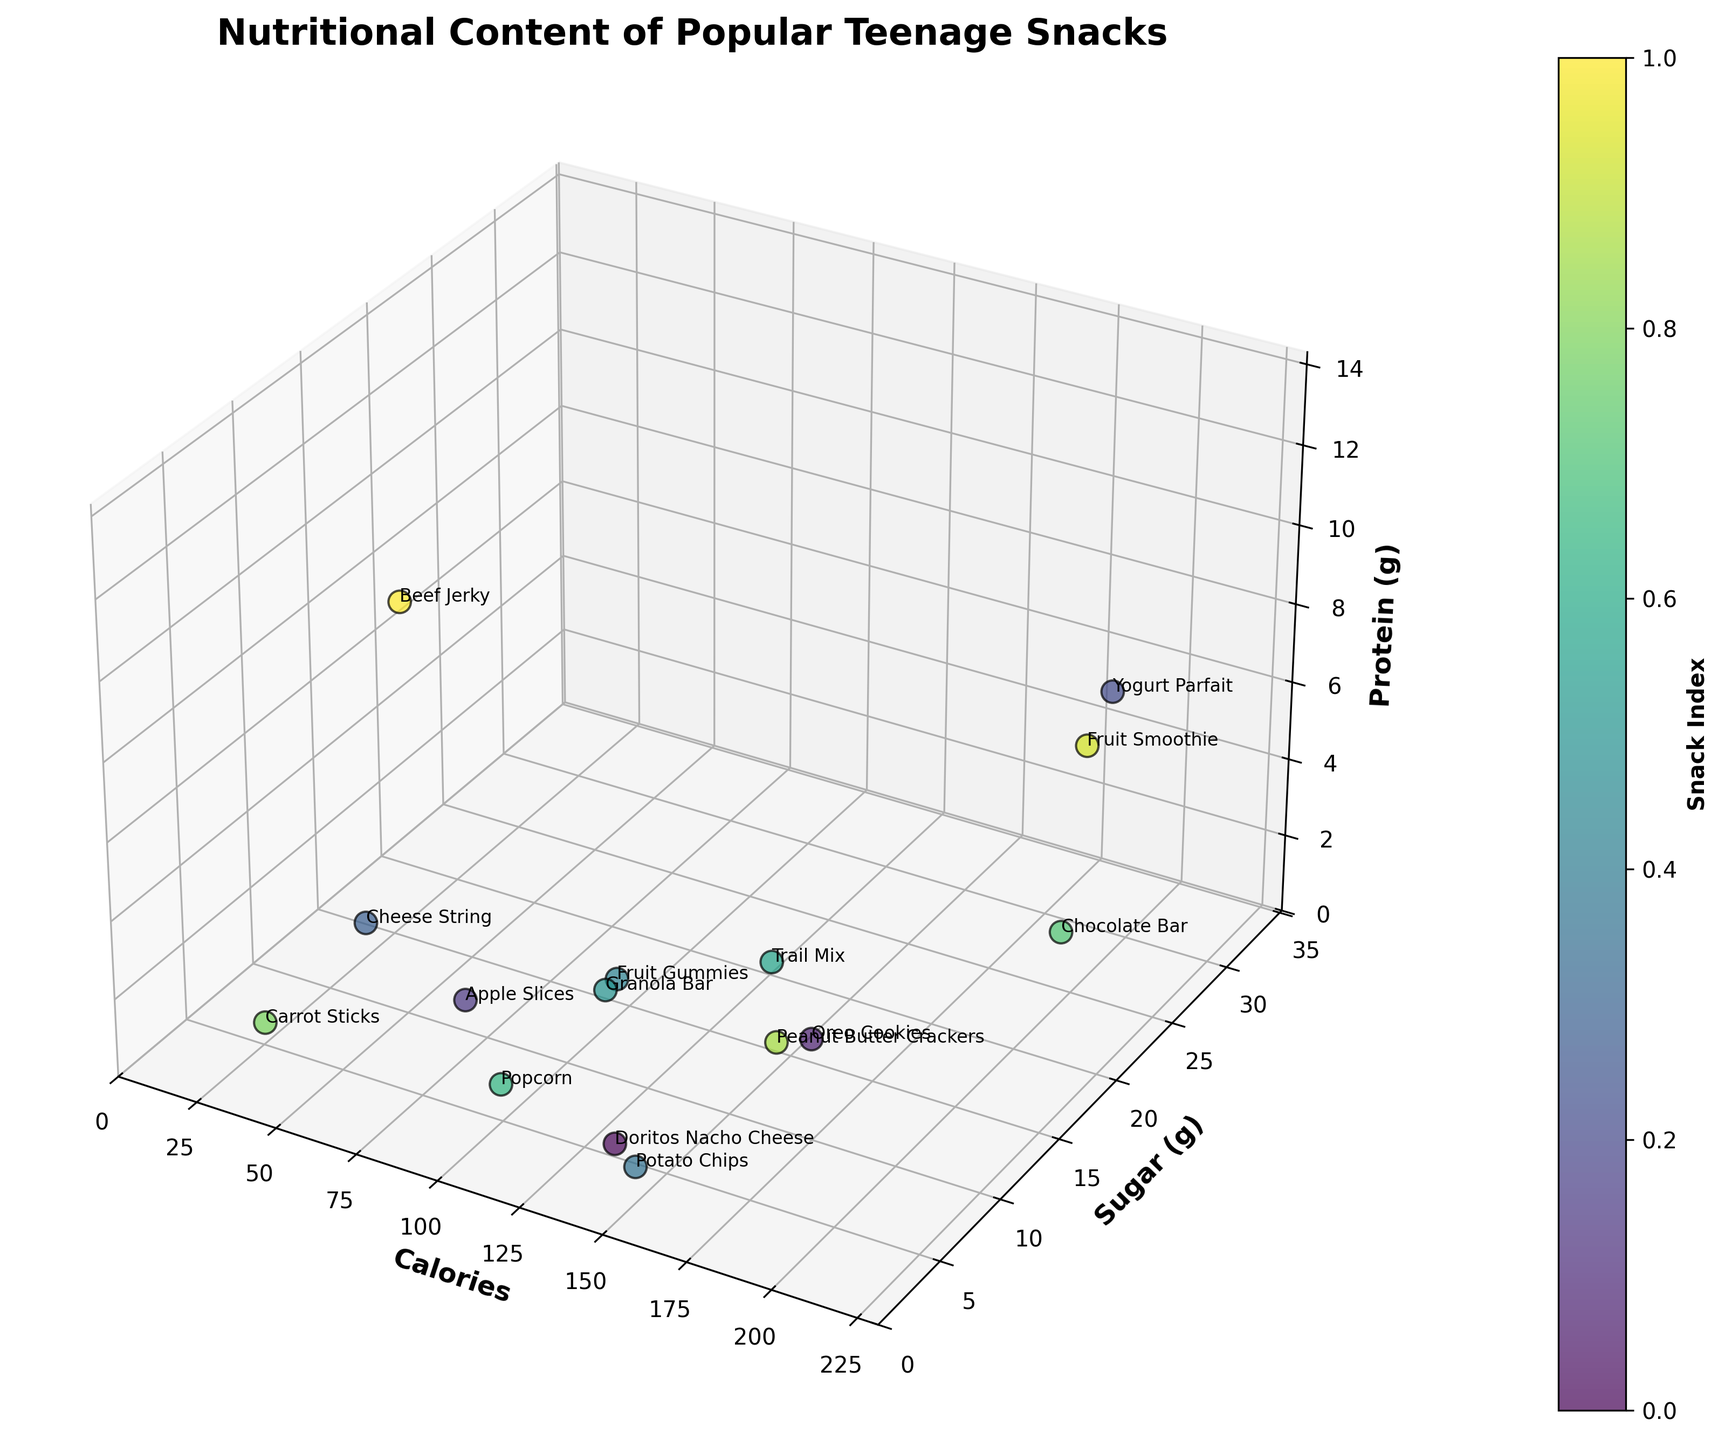What is the title of the plot? The title of the plot is prominently displayed at the top of the figure. It reads "Nutritional Content of Popular Teenage Snacks".
Answer: Nutritional Content of Popular Teenage Snacks What does the x-axis represent? The label on the x-axis specifies what it represents. It is clearly marked as "Calories".
Answer: Calories Which snack has the highest sugar content? By looking at the points along the y-axis, we can see that the snack with the highest sugar content is located at the upper limit of the y-axis values. This is the Fruit Smoothie with 32 grams of sugar.
Answer: Fruit Smoothie Which snack contains the most protein? Observing the points along the z-axis, the highest value of protein is found at the topmost point, which corresponds to Beef Jerky with 13 grams of protein.
Answer: Beef Jerky Which snacks contain zero grams of sugar? To find snacks with zero grams of sugar, look for data points along the x-axis (Calories) with their y-axis (Sugar) value at zero. These snacks are Potato Chips, Cheese String, and Popcorn.
Answer: Potato Chips, Cheese String, Popcorn How many snacks contain more than 20 grams of sugar? Count the number of data points where the y-axis value (Sugar) exceeds 20. These snacks include Yogurt Parfait and Chocolate Bar, totaling 2 snacks.
Answer: 2 Which snack has the lowest calorie count? By identifying the lowest point along the x-axis (Calories), the snack with the lowest value is Carrot Sticks with 30 calories.
Answer: Carrot Sticks What is the relationship between calories and protein content in snacks? Examine the spread of points along the x-axis (Calories) and the z-axis (Protein). Snacks with varying calories have different protein contents, showing no direct linear relationship.
Answer: No direct linear relationship Compare the sugar and protein contents of Oreo Cookies and Granola Bar. Look at the coordinates for Oreo Cookies and Granola Bar along the y-axis (Sugar) and z-axis (Protein). Oreo Cookies have 14 grams of sugar and 1 gram of protein, whereas Granola Bar has 8 grams of sugar and 3 grams of protein.
Answer: Oreo Cookies: 14g Sugar, 1g Protein; Granola Bar: 8g Sugar, 3g Protein Which snacks are closest in nutritional content? To find snacks close in nutritional content, look for points that are near one another in the 3D space of the plot. For example, Potato Chips and Granola Bar are fairly close to each other in calories, sugar, and protein content.
Answer: Potato Chips and Granola Bar 